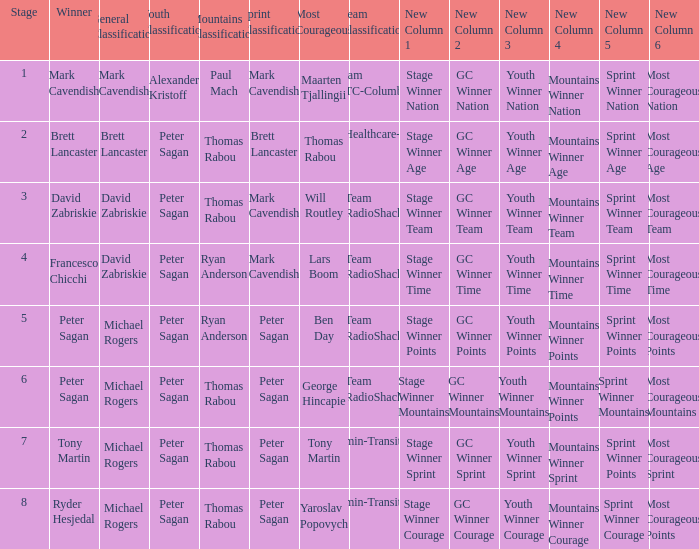When Brett Lancaster won the general classification, who won the team calssification? UnitedHealthcare-Maxxis. 